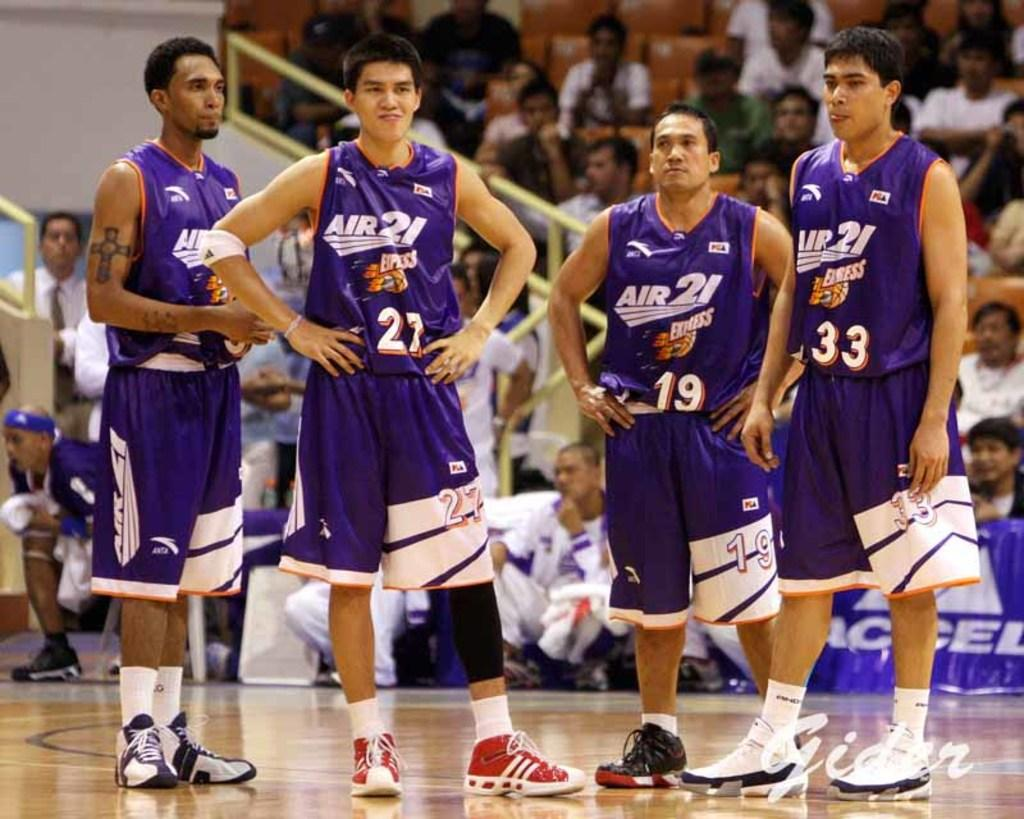<image>
Describe the image concisely. Basket ball players from the Air 21 Express basketball team are standing on the court. 